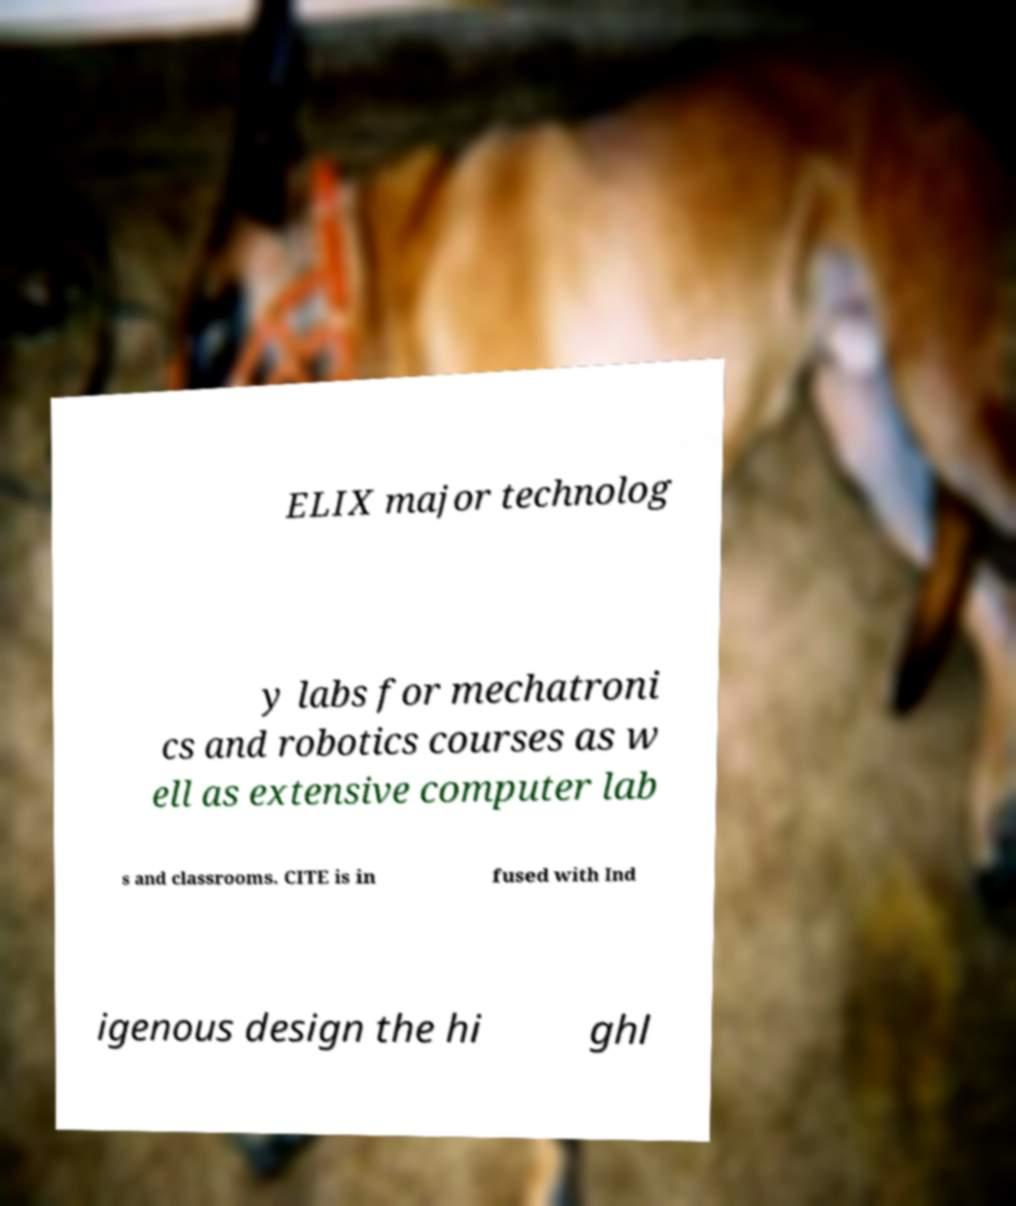Could you assist in decoding the text presented in this image and type it out clearly? ELIX major technolog y labs for mechatroni cs and robotics courses as w ell as extensive computer lab s and classrooms. CITE is in fused with Ind igenous design the hi ghl 